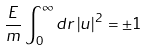<formula> <loc_0><loc_0><loc_500><loc_500>\frac { E } { m } \int _ { 0 } ^ { \infty } d r \, | u | ^ { 2 } \, = \pm 1</formula> 